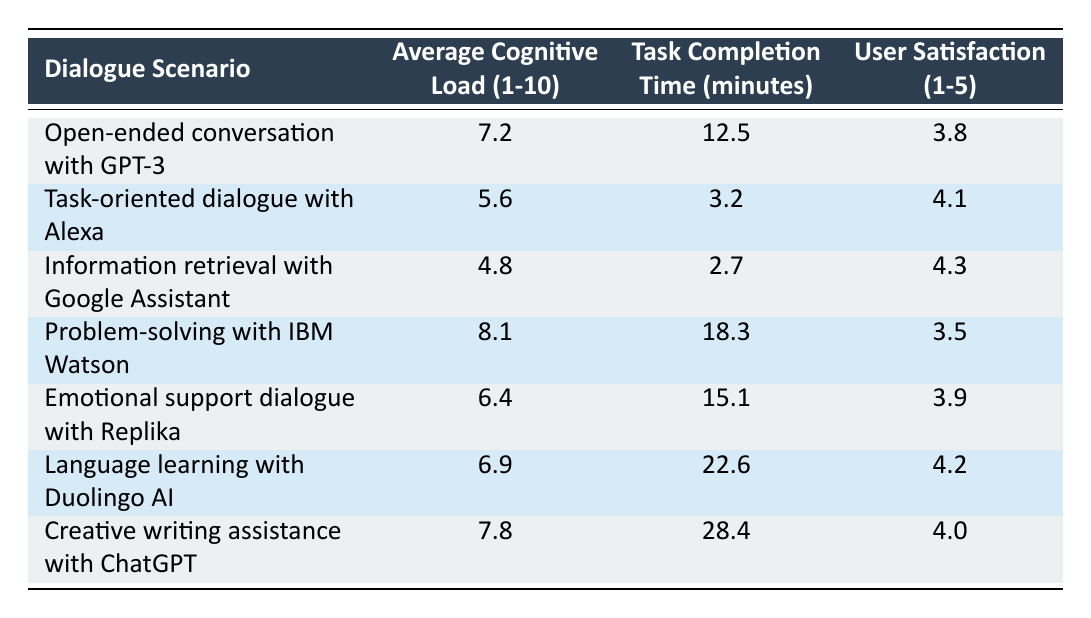What is the average cognitive load for the dialogue scenario involving Google Assistant? From the table, the average cognitive load for "Information retrieval with Google Assistant" is explicitly stated as 4.8.
Answer: 4.8 Which dialogue scenario has the highest user satisfaction rating? By examining the user satisfaction ratings for each scenario, "Task-oriented dialogue with Alexa" has the highest rating at 4.1.
Answer: Task-oriented dialogue with Alexa What is the difference in task completion time between the problem-solving scenario with IBM Watson and the information retrieval scenario with Google Assistant? The task completion time for "Problem-solving with IBM Watson" is 18.3 minutes, and for "Information retrieval with Google Assistant," it is 2.7 minutes. The difference is 18.3 - 2.7 = 15.6 minutes.
Answer: 15.6 minutes Is the average cognitive load for emotional support dialogue with Replika higher than that of task-oriented dialogue with Alexa? The average cognitive load for "Emotional support dialogue with Replika" is 6.4, while for "Task-oriented dialogue with Alexa," it is 5.6. Thus, 6.4 > 5.6, which means it is true.
Answer: Yes What are the average cognitive load and user satisfaction for creative writing assistance with ChatGPT? The average cognitive load for "Creative writing assistance with ChatGPT" is 7.8, and user satisfaction is 4.0, both values are highlighted in the respective columns.
Answer: 7.8 and 4.0 Which dialogue scenario requires the most time to complete, and what is that time? "Creative writing assistance with ChatGPT" has the highest task completion time of 28.4 minutes among all scenarios listed in the table.
Answer: 28.4 minutes What is the average user satisfaction across all the dialogue scenarios? To find the average user satisfaction, sum all ratings (3.8 + 4.1 + 4.3 + 3.5 + 3.9 + 4.2 + 4.0) = 27.8, then divide by the number of scenarios (7). Thus, 27.8 / 7 = 3.97 (approximately).
Answer: 3.97 Does the language learning scenario with Duolingo AI have a lower cognitive load than the open-ended conversation with GPT-3? The average cognitive load for "Language learning with Duolingo AI" is 6.9 and for "Open-ended conversation with GPT-3" is 7.2. Since 6.9 is less than 7.2, the statement is true.
Answer: Yes What is the combination of task completion times for the task-oriented dialogue with Alexa and information retrieval with Google Assistant? The task completion times are 3.2 minutes for "Task-oriented dialogue with Alexa" and 2.7 minutes for "Information retrieval with Google Assistant"; adding these gives 3.2 + 2.7 = 5.9 minutes.
Answer: 5.9 minutes 